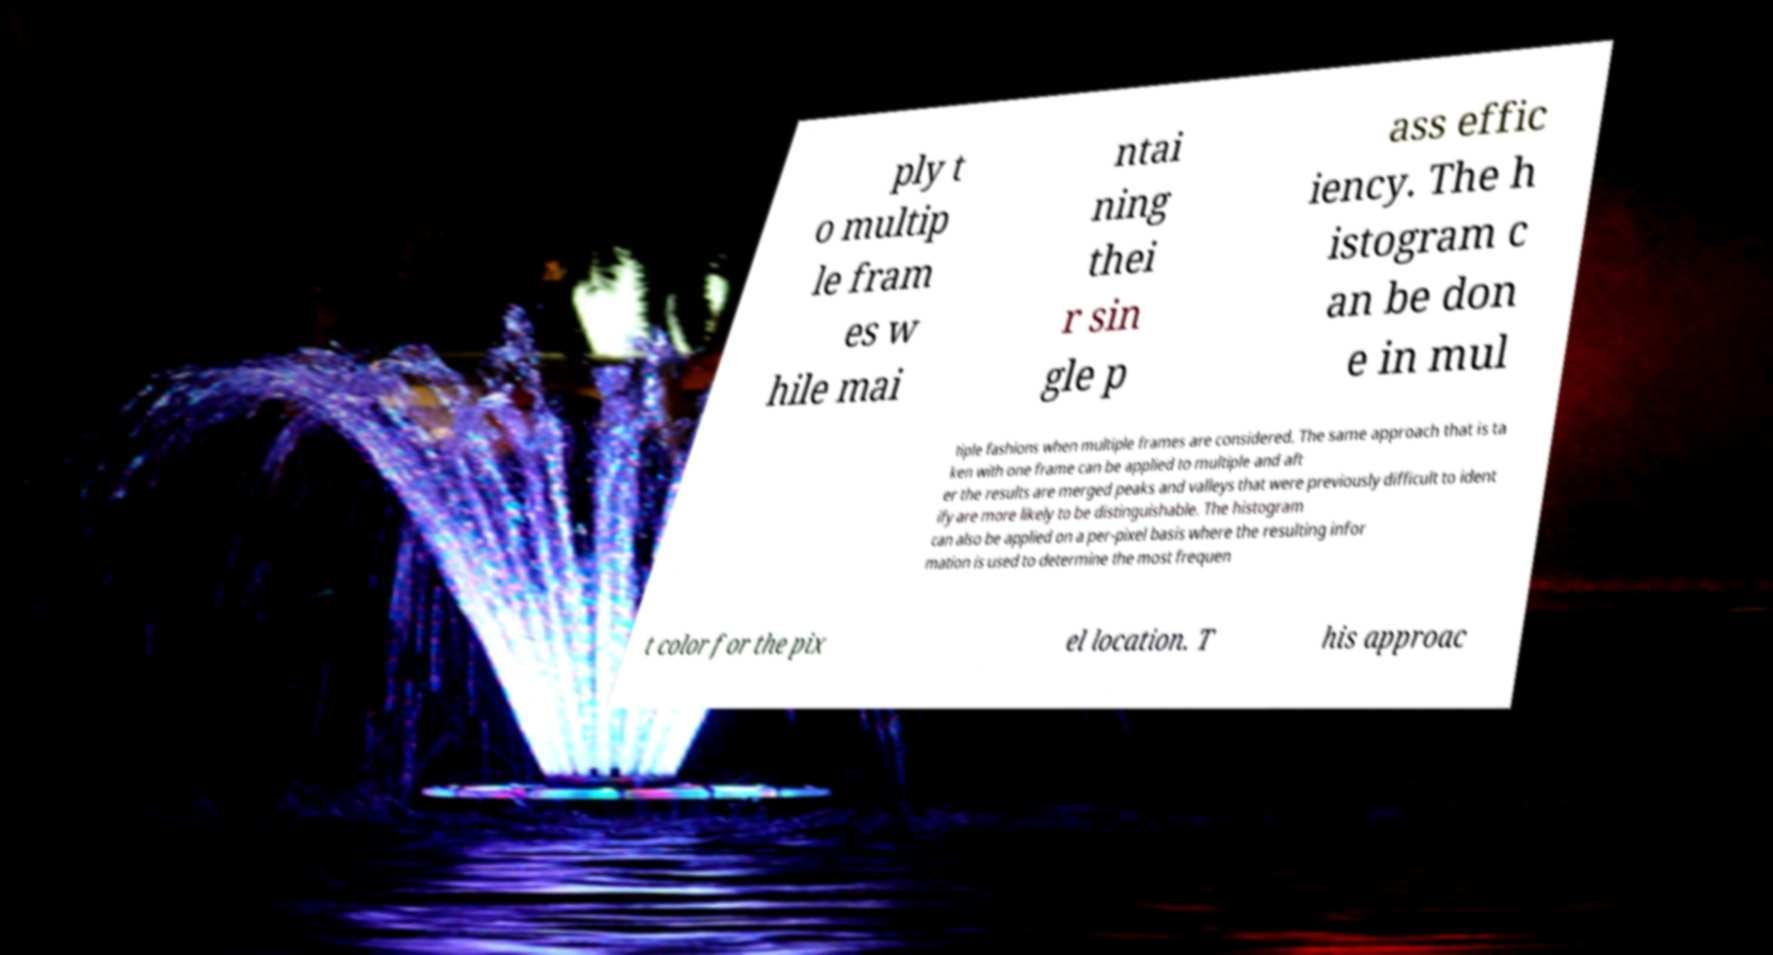For documentation purposes, I need the text within this image transcribed. Could you provide that? ply t o multip le fram es w hile mai ntai ning thei r sin gle p ass effic iency. The h istogram c an be don e in mul tiple fashions when multiple frames are considered. The same approach that is ta ken with one frame can be applied to multiple and aft er the results are merged peaks and valleys that were previously difficult to ident ify are more likely to be distinguishable. The histogram can also be applied on a per-pixel basis where the resulting infor mation is used to determine the most frequen t color for the pix el location. T his approac 